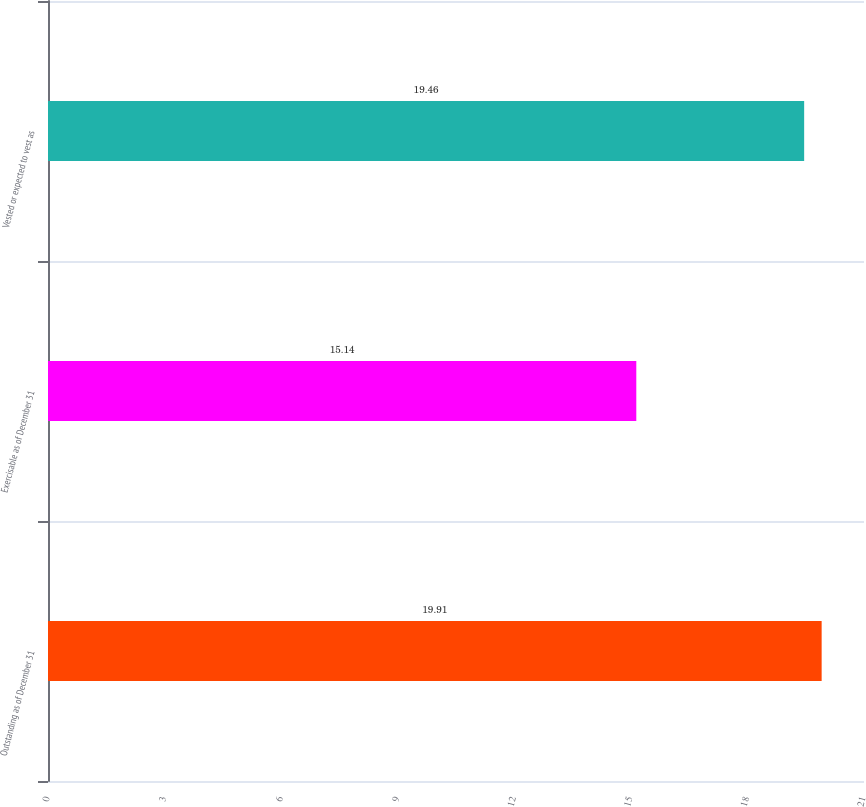Convert chart to OTSL. <chart><loc_0><loc_0><loc_500><loc_500><bar_chart><fcel>Outstanding as of December 31<fcel>Exercisable as of December 31<fcel>Vested or expected to vest as<nl><fcel>19.91<fcel>15.14<fcel>19.46<nl></chart> 